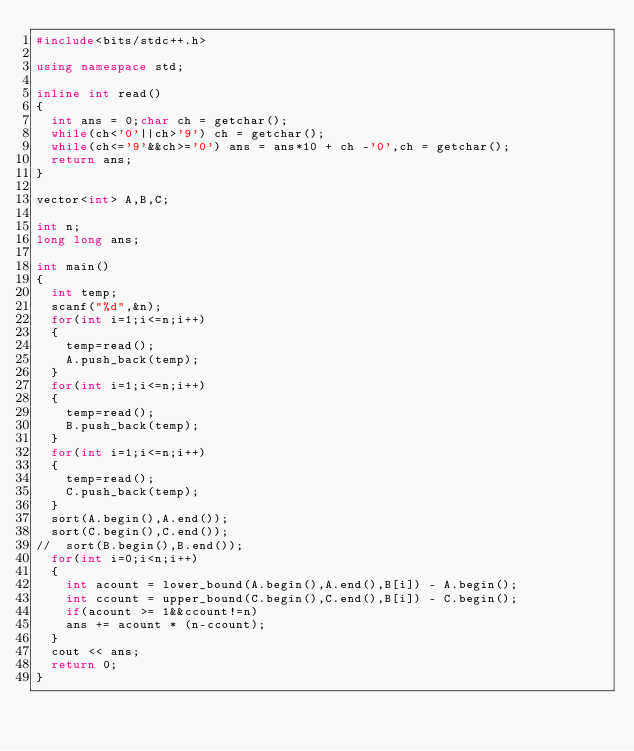<code> <loc_0><loc_0><loc_500><loc_500><_C++_>#include<bits/stdc++.h>

using namespace std;

inline int read()
{
	int ans = 0;char ch = getchar();
	while(ch<'0'||ch>'9')	ch = getchar();
	while(ch<='9'&&ch>='0')	ans = ans*10 + ch -'0',ch = getchar();
	return ans;
}

vector<int> A,B,C;

int n;
long long ans; 

int main()
{
	int temp;
	scanf("%d",&n);
	for(int i=1;i<=n;i++)
	{
		temp=read();
		A.push_back(temp);
	}
	for(int i=1;i<=n;i++)
	{
		temp=read();
		B.push_back(temp);
	}
	for(int i=1;i<=n;i++)
	{
		temp=read();
		C.push_back(temp);
	}
	sort(A.begin(),A.end());
	sort(C.begin(),C.end());
//	sort(B.begin(),B.end());
	for(int i=0;i<n;i++)
	{
		int acount = lower_bound(A.begin(),A.end(),B[i]) - A.begin();
		int ccount = upper_bound(C.begin(),C.end(),B[i]) - C.begin();
		if(acount >= 1&&ccount!=n)
		ans += acount * (n-ccount); 
	}
	cout << ans;
	return 0;
}</code> 